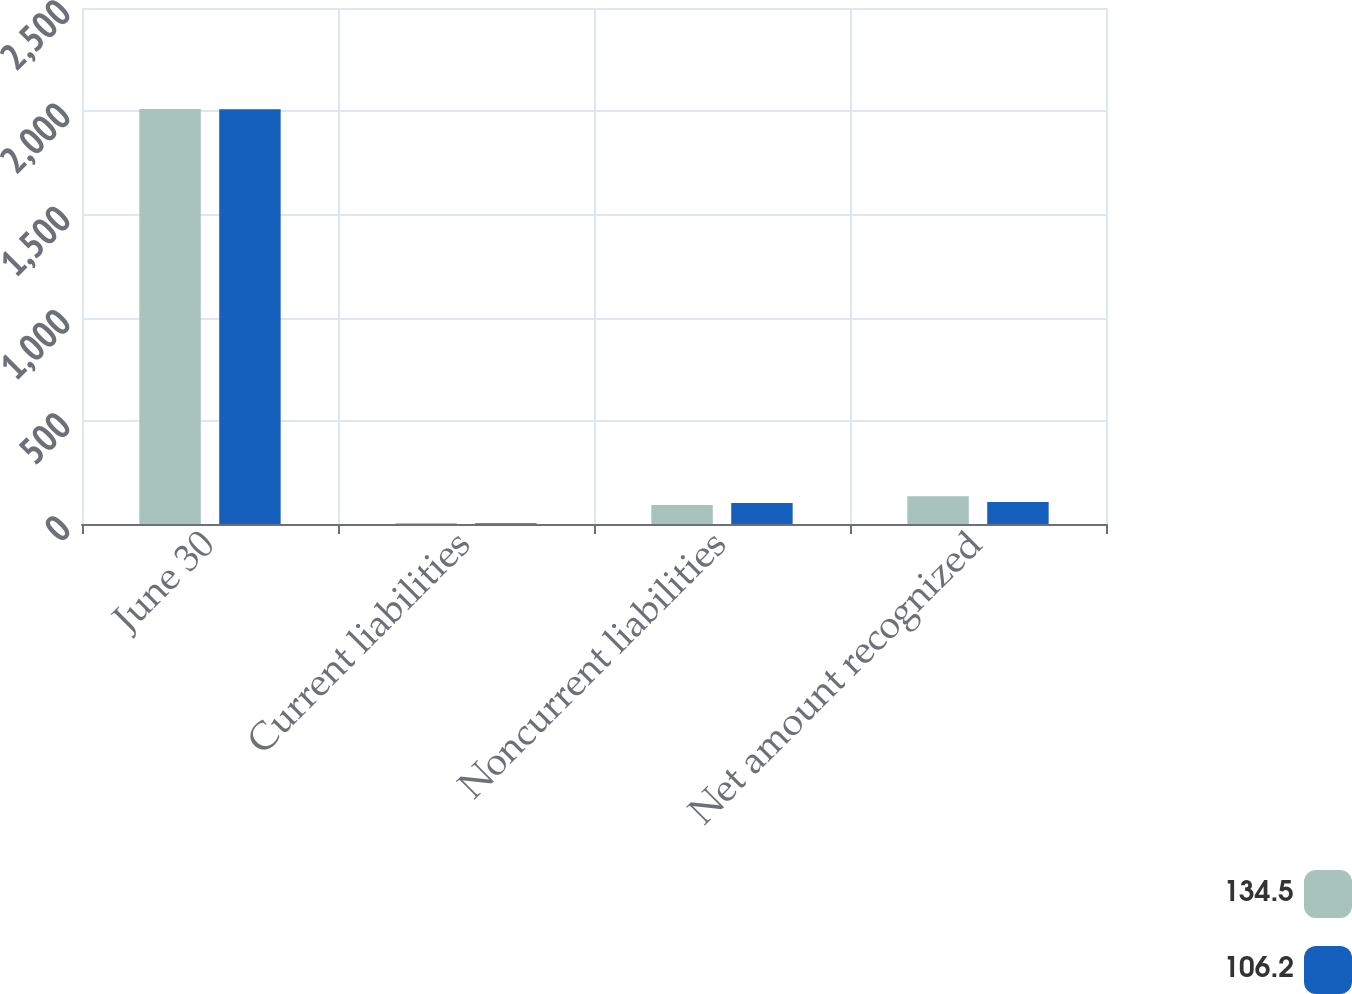<chart> <loc_0><loc_0><loc_500><loc_500><stacked_bar_chart><ecel><fcel>June 30<fcel>Current liabilities<fcel>Noncurrent liabilities<fcel>Net amount recognized<nl><fcel>134.5<fcel>2011<fcel>4.5<fcel>92.5<fcel>134.5<nl><fcel>106.2<fcel>2010<fcel>3.9<fcel>102.3<fcel>106.2<nl></chart> 